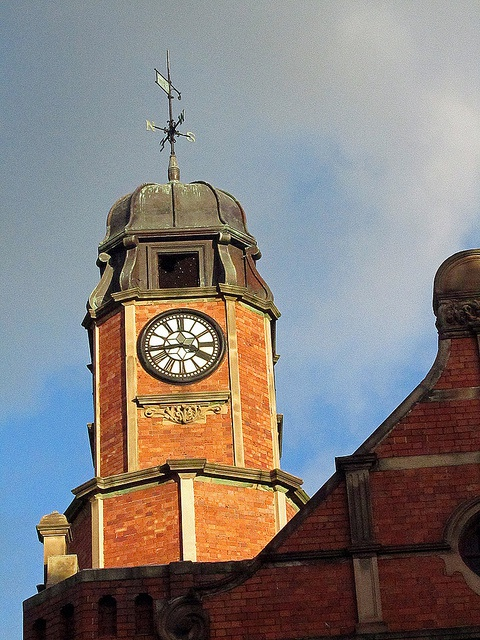Describe the objects in this image and their specific colors. I can see a clock in gray, white, black, and olive tones in this image. 